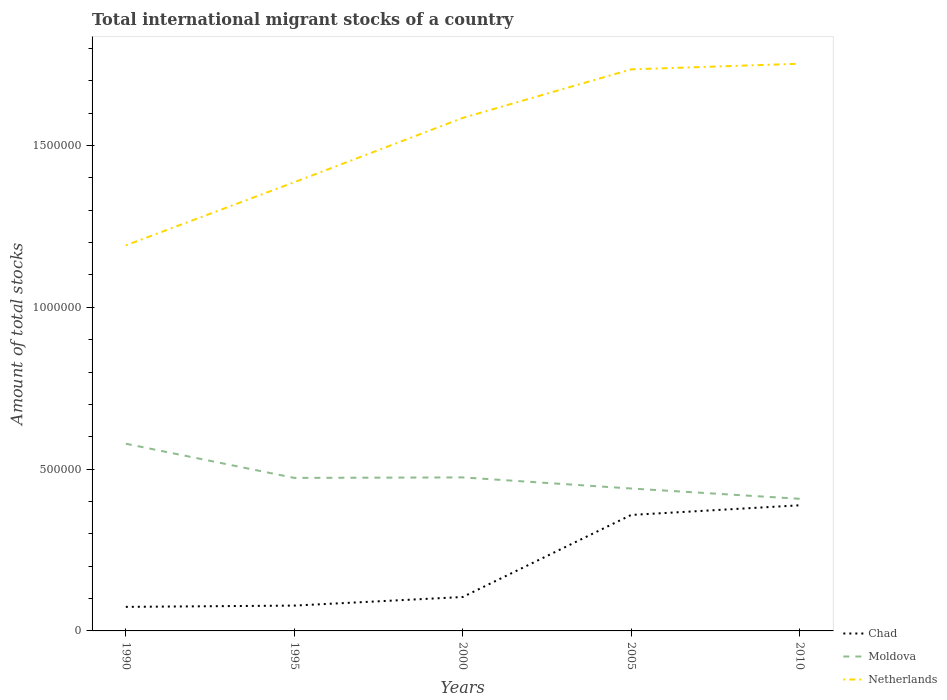How many different coloured lines are there?
Offer a terse response. 3. Does the line corresponding to Moldova intersect with the line corresponding to Chad?
Your answer should be very brief. No. Is the number of lines equal to the number of legend labels?
Your answer should be compact. Yes. Across all years, what is the maximum amount of total stocks in in Chad?
Ensure brevity in your answer.  7.43e+04. What is the total amount of total stocks in in Moldova in the graph?
Your response must be concise. -1500. What is the difference between the highest and the second highest amount of total stocks in in Chad?
Provide a succinct answer. 3.14e+05. Is the amount of total stocks in in Chad strictly greater than the amount of total stocks in in Moldova over the years?
Make the answer very short. Yes. How many years are there in the graph?
Ensure brevity in your answer.  5. Where does the legend appear in the graph?
Make the answer very short. Bottom right. What is the title of the graph?
Ensure brevity in your answer.  Total international migrant stocks of a country. What is the label or title of the Y-axis?
Give a very brief answer. Amount of total stocks. What is the Amount of total stocks in Chad in 1990?
Keep it short and to the point. 7.43e+04. What is the Amount of total stocks in Moldova in 1990?
Ensure brevity in your answer.  5.78e+05. What is the Amount of total stocks of Netherlands in 1990?
Provide a succinct answer. 1.19e+06. What is the Amount of total stocks in Chad in 1995?
Provide a succinct answer. 7.83e+04. What is the Amount of total stocks of Moldova in 1995?
Keep it short and to the point. 4.73e+05. What is the Amount of total stocks in Netherlands in 1995?
Ensure brevity in your answer.  1.39e+06. What is the Amount of total stocks of Chad in 2000?
Ensure brevity in your answer.  1.05e+05. What is the Amount of total stocks in Moldova in 2000?
Make the answer very short. 4.74e+05. What is the Amount of total stocks in Netherlands in 2000?
Your response must be concise. 1.59e+06. What is the Amount of total stocks of Chad in 2005?
Make the answer very short. 3.58e+05. What is the Amount of total stocks in Moldova in 2005?
Your answer should be very brief. 4.40e+05. What is the Amount of total stocks of Netherlands in 2005?
Ensure brevity in your answer.  1.74e+06. What is the Amount of total stocks of Chad in 2010?
Offer a terse response. 3.88e+05. What is the Amount of total stocks of Moldova in 2010?
Provide a short and direct response. 4.08e+05. What is the Amount of total stocks in Netherlands in 2010?
Make the answer very short. 1.75e+06. Across all years, what is the maximum Amount of total stocks of Chad?
Make the answer very short. 3.88e+05. Across all years, what is the maximum Amount of total stocks in Moldova?
Keep it short and to the point. 5.78e+05. Across all years, what is the maximum Amount of total stocks of Netherlands?
Provide a succinct answer. 1.75e+06. Across all years, what is the minimum Amount of total stocks in Chad?
Give a very brief answer. 7.43e+04. Across all years, what is the minimum Amount of total stocks in Moldova?
Your response must be concise. 4.08e+05. Across all years, what is the minimum Amount of total stocks of Netherlands?
Keep it short and to the point. 1.19e+06. What is the total Amount of total stocks of Chad in the graph?
Give a very brief answer. 1.00e+06. What is the total Amount of total stocks in Moldova in the graph?
Offer a very short reply. 2.37e+06. What is the total Amount of total stocks in Netherlands in the graph?
Ensure brevity in your answer.  7.65e+06. What is the difference between the Amount of total stocks of Chad in 1990 and that in 1995?
Your answer should be very brief. -3917. What is the difference between the Amount of total stocks of Moldova in 1990 and that in 1995?
Keep it short and to the point. 1.06e+05. What is the difference between the Amount of total stocks of Netherlands in 1990 and that in 1995?
Offer a very short reply. -1.95e+05. What is the difference between the Amount of total stocks in Chad in 1990 and that in 2000?
Provide a short and direct response. -3.05e+04. What is the difference between the Amount of total stocks of Moldova in 1990 and that in 2000?
Your response must be concise. 1.04e+05. What is the difference between the Amount of total stocks in Netherlands in 1990 and that in 2000?
Give a very brief answer. -3.94e+05. What is the difference between the Amount of total stocks of Chad in 1990 and that in 2005?
Ensure brevity in your answer.  -2.84e+05. What is the difference between the Amount of total stocks in Moldova in 1990 and that in 2005?
Make the answer very short. 1.38e+05. What is the difference between the Amount of total stocks of Netherlands in 1990 and that in 2005?
Your answer should be compact. -5.44e+05. What is the difference between the Amount of total stocks of Chad in 1990 and that in 2010?
Your answer should be very brief. -3.14e+05. What is the difference between the Amount of total stocks of Moldova in 1990 and that in 2010?
Make the answer very short. 1.70e+05. What is the difference between the Amount of total stocks in Netherlands in 1990 and that in 2010?
Provide a succinct answer. -5.61e+05. What is the difference between the Amount of total stocks of Chad in 1995 and that in 2000?
Offer a very short reply. -2.66e+04. What is the difference between the Amount of total stocks in Moldova in 1995 and that in 2000?
Your answer should be very brief. -1500. What is the difference between the Amount of total stocks in Netherlands in 1995 and that in 2000?
Ensure brevity in your answer.  -1.99e+05. What is the difference between the Amount of total stocks in Chad in 1995 and that in 2005?
Provide a short and direct response. -2.80e+05. What is the difference between the Amount of total stocks of Moldova in 1995 and that in 2005?
Offer a terse response. 3.28e+04. What is the difference between the Amount of total stocks of Netherlands in 1995 and that in 2005?
Ensure brevity in your answer.  -3.49e+05. What is the difference between the Amount of total stocks of Chad in 1995 and that in 2010?
Make the answer very short. -3.10e+05. What is the difference between the Amount of total stocks in Moldova in 1995 and that in 2010?
Ensure brevity in your answer.  6.46e+04. What is the difference between the Amount of total stocks in Netherlands in 1995 and that in 2010?
Provide a short and direct response. -3.66e+05. What is the difference between the Amount of total stocks in Chad in 2000 and that in 2005?
Provide a short and direct response. -2.54e+05. What is the difference between the Amount of total stocks in Moldova in 2000 and that in 2005?
Provide a succinct answer. 3.43e+04. What is the difference between the Amount of total stocks of Netherlands in 2000 and that in 2005?
Offer a very short reply. -1.50e+05. What is the difference between the Amount of total stocks of Chad in 2000 and that in 2010?
Offer a very short reply. -2.83e+05. What is the difference between the Amount of total stocks of Moldova in 2000 and that in 2010?
Make the answer very short. 6.61e+04. What is the difference between the Amount of total stocks in Netherlands in 2000 and that in 2010?
Make the answer very short. -1.67e+05. What is the difference between the Amount of total stocks of Chad in 2005 and that in 2010?
Provide a succinct answer. -2.98e+04. What is the difference between the Amount of total stocks of Moldova in 2005 and that in 2010?
Provide a succinct answer. 3.18e+04. What is the difference between the Amount of total stocks in Netherlands in 2005 and that in 2010?
Offer a terse response. -1.74e+04. What is the difference between the Amount of total stocks of Chad in 1990 and the Amount of total stocks of Moldova in 1995?
Make the answer very short. -3.99e+05. What is the difference between the Amount of total stocks in Chad in 1990 and the Amount of total stocks in Netherlands in 1995?
Your answer should be very brief. -1.31e+06. What is the difference between the Amount of total stocks of Moldova in 1990 and the Amount of total stocks of Netherlands in 1995?
Provide a succinct answer. -8.08e+05. What is the difference between the Amount of total stocks of Chad in 1990 and the Amount of total stocks of Moldova in 2000?
Make the answer very short. -4.00e+05. What is the difference between the Amount of total stocks of Chad in 1990 and the Amount of total stocks of Netherlands in 2000?
Your answer should be compact. -1.51e+06. What is the difference between the Amount of total stocks in Moldova in 1990 and the Amount of total stocks in Netherlands in 2000?
Offer a very short reply. -1.01e+06. What is the difference between the Amount of total stocks in Chad in 1990 and the Amount of total stocks in Moldova in 2005?
Give a very brief answer. -3.66e+05. What is the difference between the Amount of total stocks in Chad in 1990 and the Amount of total stocks in Netherlands in 2005?
Offer a terse response. -1.66e+06. What is the difference between the Amount of total stocks in Moldova in 1990 and the Amount of total stocks in Netherlands in 2005?
Make the answer very short. -1.16e+06. What is the difference between the Amount of total stocks of Chad in 1990 and the Amount of total stocks of Moldova in 2010?
Provide a short and direct response. -3.34e+05. What is the difference between the Amount of total stocks in Chad in 1990 and the Amount of total stocks in Netherlands in 2010?
Provide a succinct answer. -1.68e+06. What is the difference between the Amount of total stocks in Moldova in 1990 and the Amount of total stocks in Netherlands in 2010?
Keep it short and to the point. -1.17e+06. What is the difference between the Amount of total stocks of Chad in 1995 and the Amount of total stocks of Moldova in 2000?
Give a very brief answer. -3.96e+05. What is the difference between the Amount of total stocks in Chad in 1995 and the Amount of total stocks in Netherlands in 2000?
Keep it short and to the point. -1.51e+06. What is the difference between the Amount of total stocks of Moldova in 1995 and the Amount of total stocks of Netherlands in 2000?
Your answer should be compact. -1.11e+06. What is the difference between the Amount of total stocks in Chad in 1995 and the Amount of total stocks in Moldova in 2005?
Give a very brief answer. -3.62e+05. What is the difference between the Amount of total stocks of Chad in 1995 and the Amount of total stocks of Netherlands in 2005?
Keep it short and to the point. -1.66e+06. What is the difference between the Amount of total stocks of Moldova in 1995 and the Amount of total stocks of Netherlands in 2005?
Your response must be concise. -1.26e+06. What is the difference between the Amount of total stocks of Chad in 1995 and the Amount of total stocks of Moldova in 2010?
Make the answer very short. -3.30e+05. What is the difference between the Amount of total stocks in Chad in 1995 and the Amount of total stocks in Netherlands in 2010?
Your answer should be very brief. -1.67e+06. What is the difference between the Amount of total stocks in Moldova in 1995 and the Amount of total stocks in Netherlands in 2010?
Keep it short and to the point. -1.28e+06. What is the difference between the Amount of total stocks of Chad in 2000 and the Amount of total stocks of Moldova in 2005?
Make the answer very short. -3.35e+05. What is the difference between the Amount of total stocks of Chad in 2000 and the Amount of total stocks of Netherlands in 2005?
Your answer should be very brief. -1.63e+06. What is the difference between the Amount of total stocks in Moldova in 2000 and the Amount of total stocks in Netherlands in 2005?
Keep it short and to the point. -1.26e+06. What is the difference between the Amount of total stocks of Chad in 2000 and the Amount of total stocks of Moldova in 2010?
Offer a very short reply. -3.03e+05. What is the difference between the Amount of total stocks of Chad in 2000 and the Amount of total stocks of Netherlands in 2010?
Make the answer very short. -1.65e+06. What is the difference between the Amount of total stocks in Moldova in 2000 and the Amount of total stocks in Netherlands in 2010?
Your answer should be compact. -1.28e+06. What is the difference between the Amount of total stocks of Chad in 2005 and the Amount of total stocks of Moldova in 2010?
Keep it short and to the point. -4.99e+04. What is the difference between the Amount of total stocks of Chad in 2005 and the Amount of total stocks of Netherlands in 2010?
Offer a very short reply. -1.39e+06. What is the difference between the Amount of total stocks of Moldova in 2005 and the Amount of total stocks of Netherlands in 2010?
Your response must be concise. -1.31e+06. What is the average Amount of total stocks in Chad per year?
Keep it short and to the point. 2.01e+05. What is the average Amount of total stocks of Moldova per year?
Ensure brevity in your answer.  4.75e+05. What is the average Amount of total stocks of Netherlands per year?
Provide a succinct answer. 1.53e+06. In the year 1990, what is the difference between the Amount of total stocks of Chad and Amount of total stocks of Moldova?
Your answer should be compact. -5.04e+05. In the year 1990, what is the difference between the Amount of total stocks of Chad and Amount of total stocks of Netherlands?
Make the answer very short. -1.12e+06. In the year 1990, what is the difference between the Amount of total stocks in Moldova and Amount of total stocks in Netherlands?
Make the answer very short. -6.13e+05. In the year 1995, what is the difference between the Amount of total stocks of Chad and Amount of total stocks of Moldova?
Make the answer very short. -3.95e+05. In the year 1995, what is the difference between the Amount of total stocks in Chad and Amount of total stocks in Netherlands?
Offer a very short reply. -1.31e+06. In the year 1995, what is the difference between the Amount of total stocks of Moldova and Amount of total stocks of Netherlands?
Your answer should be very brief. -9.14e+05. In the year 2000, what is the difference between the Amount of total stocks of Chad and Amount of total stocks of Moldova?
Your answer should be compact. -3.70e+05. In the year 2000, what is the difference between the Amount of total stocks of Chad and Amount of total stocks of Netherlands?
Ensure brevity in your answer.  -1.48e+06. In the year 2000, what is the difference between the Amount of total stocks of Moldova and Amount of total stocks of Netherlands?
Your answer should be very brief. -1.11e+06. In the year 2005, what is the difference between the Amount of total stocks of Chad and Amount of total stocks of Moldova?
Your response must be concise. -8.17e+04. In the year 2005, what is the difference between the Amount of total stocks of Chad and Amount of total stocks of Netherlands?
Ensure brevity in your answer.  -1.38e+06. In the year 2005, what is the difference between the Amount of total stocks of Moldova and Amount of total stocks of Netherlands?
Make the answer very short. -1.30e+06. In the year 2010, what is the difference between the Amount of total stocks in Chad and Amount of total stocks in Moldova?
Your response must be concise. -2.01e+04. In the year 2010, what is the difference between the Amount of total stocks of Chad and Amount of total stocks of Netherlands?
Provide a succinct answer. -1.36e+06. In the year 2010, what is the difference between the Amount of total stocks in Moldova and Amount of total stocks in Netherlands?
Provide a short and direct response. -1.34e+06. What is the ratio of the Amount of total stocks in Chad in 1990 to that in 1995?
Give a very brief answer. 0.95. What is the ratio of the Amount of total stocks in Moldova in 1990 to that in 1995?
Provide a short and direct response. 1.22. What is the ratio of the Amount of total stocks in Netherlands in 1990 to that in 1995?
Make the answer very short. 0.86. What is the ratio of the Amount of total stocks of Chad in 1990 to that in 2000?
Your response must be concise. 0.71. What is the ratio of the Amount of total stocks of Moldova in 1990 to that in 2000?
Your answer should be very brief. 1.22. What is the ratio of the Amount of total stocks in Netherlands in 1990 to that in 2000?
Make the answer very short. 0.75. What is the ratio of the Amount of total stocks of Chad in 1990 to that in 2005?
Keep it short and to the point. 0.21. What is the ratio of the Amount of total stocks in Moldova in 1990 to that in 2005?
Your answer should be compact. 1.31. What is the ratio of the Amount of total stocks in Netherlands in 1990 to that in 2005?
Make the answer very short. 0.69. What is the ratio of the Amount of total stocks of Chad in 1990 to that in 2010?
Ensure brevity in your answer.  0.19. What is the ratio of the Amount of total stocks of Moldova in 1990 to that in 2010?
Offer a very short reply. 1.42. What is the ratio of the Amount of total stocks in Netherlands in 1990 to that in 2010?
Your response must be concise. 0.68. What is the ratio of the Amount of total stocks of Chad in 1995 to that in 2000?
Offer a very short reply. 0.75. What is the ratio of the Amount of total stocks of Moldova in 1995 to that in 2000?
Ensure brevity in your answer.  1. What is the ratio of the Amount of total stocks of Netherlands in 1995 to that in 2000?
Keep it short and to the point. 0.87. What is the ratio of the Amount of total stocks of Chad in 1995 to that in 2005?
Provide a succinct answer. 0.22. What is the ratio of the Amount of total stocks of Moldova in 1995 to that in 2005?
Give a very brief answer. 1.07. What is the ratio of the Amount of total stocks of Netherlands in 1995 to that in 2005?
Your answer should be compact. 0.8. What is the ratio of the Amount of total stocks in Chad in 1995 to that in 2010?
Offer a terse response. 0.2. What is the ratio of the Amount of total stocks of Moldova in 1995 to that in 2010?
Offer a very short reply. 1.16. What is the ratio of the Amount of total stocks in Netherlands in 1995 to that in 2010?
Your response must be concise. 0.79. What is the ratio of the Amount of total stocks of Chad in 2000 to that in 2005?
Provide a succinct answer. 0.29. What is the ratio of the Amount of total stocks of Moldova in 2000 to that in 2005?
Provide a succinct answer. 1.08. What is the ratio of the Amount of total stocks in Netherlands in 2000 to that in 2005?
Provide a short and direct response. 0.91. What is the ratio of the Amount of total stocks of Chad in 2000 to that in 2010?
Your answer should be very brief. 0.27. What is the ratio of the Amount of total stocks of Moldova in 2000 to that in 2010?
Your answer should be very brief. 1.16. What is the ratio of the Amount of total stocks of Netherlands in 2000 to that in 2010?
Your answer should be very brief. 0.9. What is the ratio of the Amount of total stocks in Chad in 2005 to that in 2010?
Make the answer very short. 0.92. What is the ratio of the Amount of total stocks of Moldova in 2005 to that in 2010?
Keep it short and to the point. 1.08. What is the difference between the highest and the second highest Amount of total stocks of Chad?
Ensure brevity in your answer.  2.98e+04. What is the difference between the highest and the second highest Amount of total stocks in Moldova?
Make the answer very short. 1.04e+05. What is the difference between the highest and the second highest Amount of total stocks in Netherlands?
Provide a short and direct response. 1.74e+04. What is the difference between the highest and the lowest Amount of total stocks in Chad?
Provide a short and direct response. 3.14e+05. What is the difference between the highest and the lowest Amount of total stocks of Moldova?
Give a very brief answer. 1.70e+05. What is the difference between the highest and the lowest Amount of total stocks of Netherlands?
Ensure brevity in your answer.  5.61e+05. 